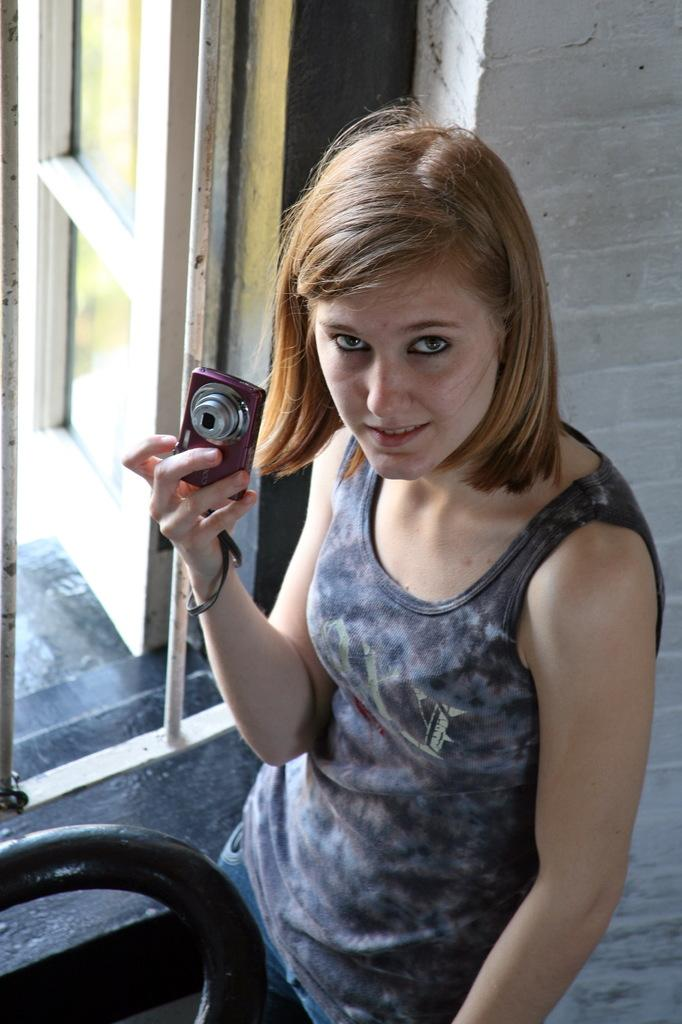Who is the main subject in the image? There is a girl in the image. What is the girl holding in her hand? The girl is holding a camera in her hand. How is the girl dressed in the image? The girl is wearing a top and trousers. What can be seen on the left side of the image? There is a window on the left side of the image. What type of guitar is the girl playing in the image? There is no guitar present in the image; the girl is holding a camera. Can you tell me how many frogs are sitting on the girl's shoulder in the image? There are no frogs present in the image; the girl is holding a camera and wearing a top and trousers. 